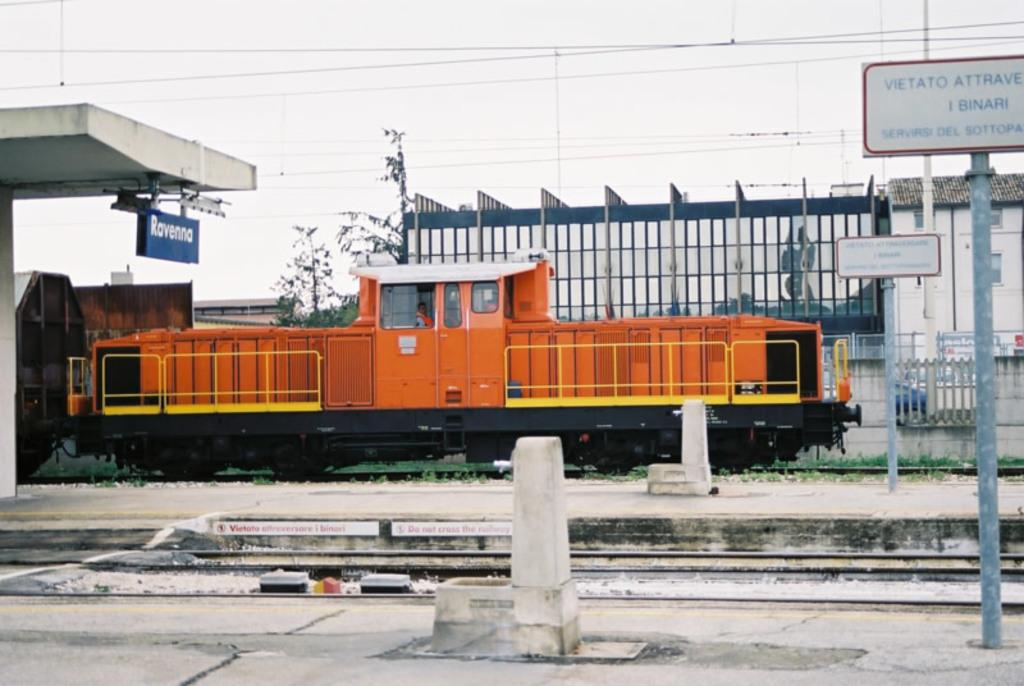Provide a one-sentence caption for the provided image. An orange train parked under a sign that says Ravenna. 